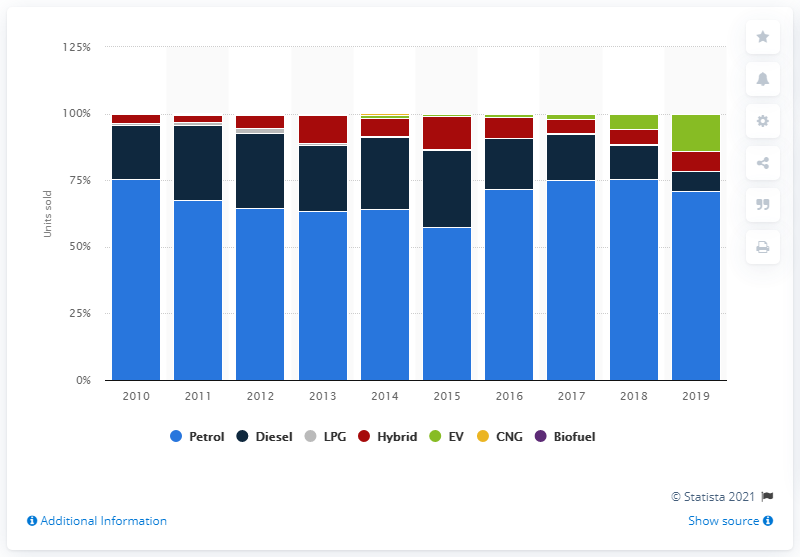Specify some key components in this picture. In 2019, approximately 7.3% of the cars in the Netherlands were fueled by diesel. 